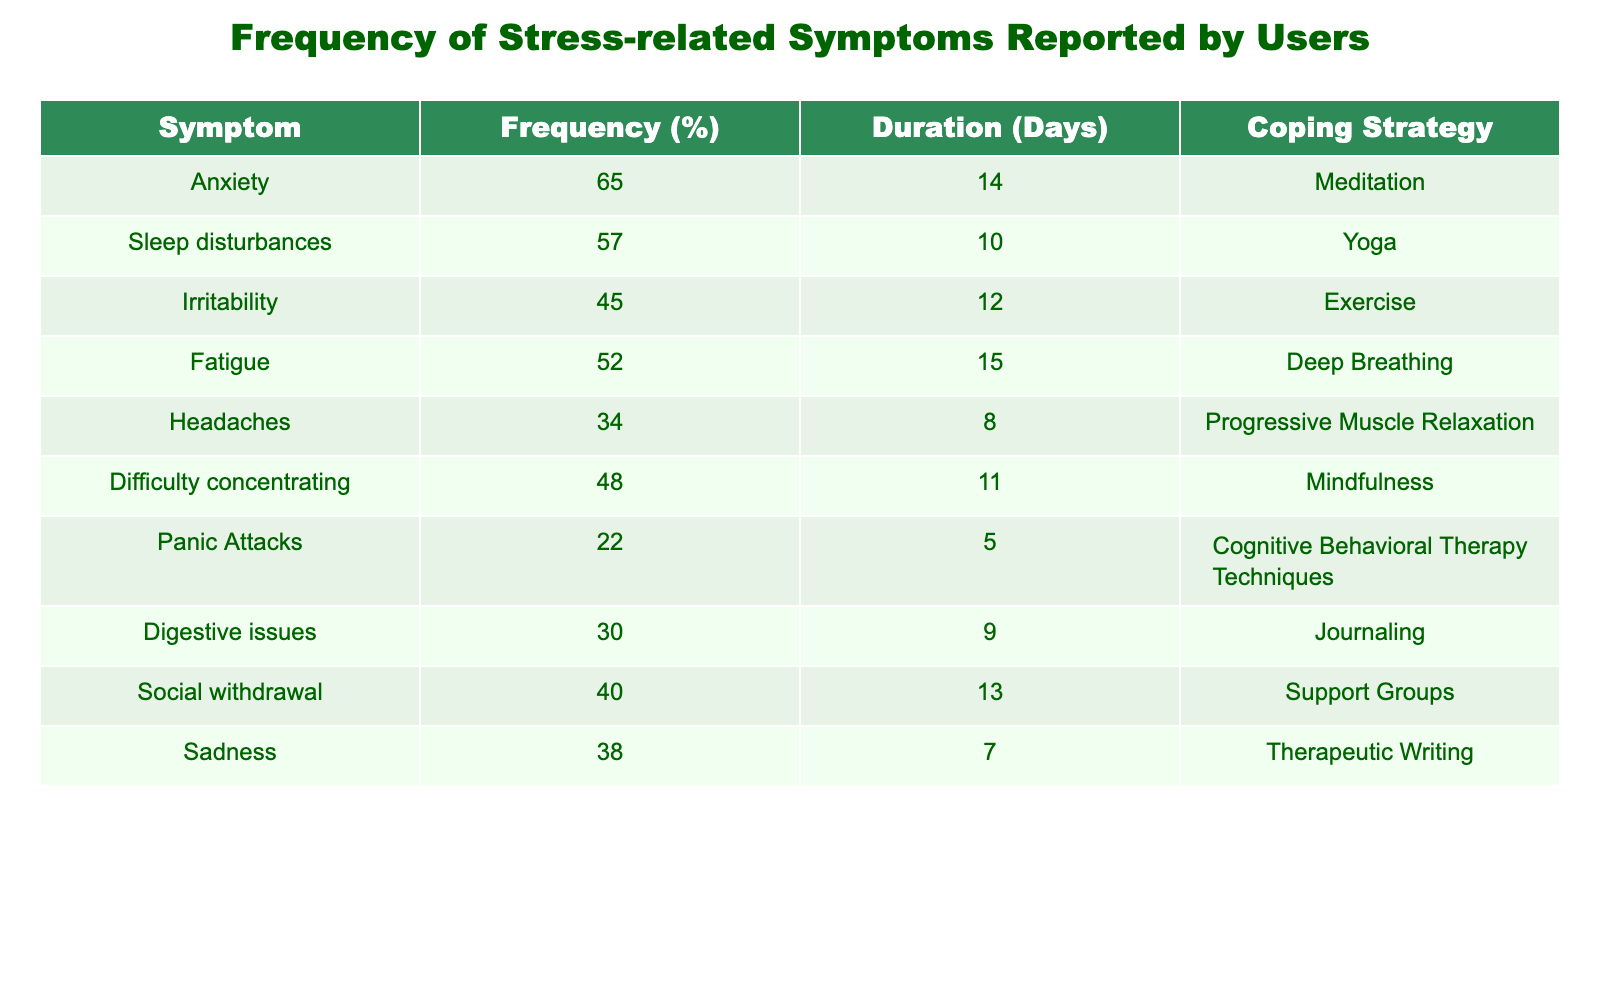What symptom has the highest frequency reported? The symptom with the highest frequency is identified by looking at the "Frequency (%)" column. Anxiety has the highest reported frequency at 65%.
Answer: Anxiety What coping strategy is associated with the longest duration of symptoms? To find the coping strategy associated with the longest duration, we compare the "Duration (Days)" column. Fatigue has a duration of 15 days, which is higher than the other symptoms, and its coping strategy is Deep Breathing.
Answer: Deep Breathing Is it true that panic attacks are experienced by more than 20% of users? The data shows that panic attacks have a frequency of 22%. Since this is greater than 20%, the statement is true.
Answer: Yes What is the average frequency of all symptoms combined? To find the average frequency, we first add up all the frequency values: (65 + 57 + 45 + 52 + 34 + 48 + 22 + 30 + 40 + 38) =  431. Then divide by the number of symptoms (10): 431 / 10 = 43.1.
Answer: 43.1 Which symptom is reported to have the shortest duration? We analyze the "Duration (Days)" column for the minimum value. Panic Attacks have the shortest duration at 5 days.
Answer: Panic Attacks How many symptoms are reported by at least 40% of users? By referring to the "Frequency (%)" column, we count the symptoms with frequencies of 40% or more: Anxiety (65%), Sleep disturbances (57%), Fatigue (52%), Difficulty concentrating (48%), Social withdrawal (40%). This totals to 5 symptoms.
Answer: 5 What coping strategy is most frequently associated with symptoms reported by users? To find the most frequent coping strategy, we’d check if any strategies are repeated among the symptoms. Each symptom has a unique coping strategy listed, indicating no repetitions. Therefore, there is no most frequent coping strategy.
Answer: None What is the difference in duration between symptoms with the highest and lowest reported frequencies? The symptom with the highest frequency is Anxiety with a duration of 14 days, while the symptom with the lowest frequency is Panic Attacks with a duration of 5 days. The difference in duration is 14 - 5 = 9 days.
Answer: 9 days 